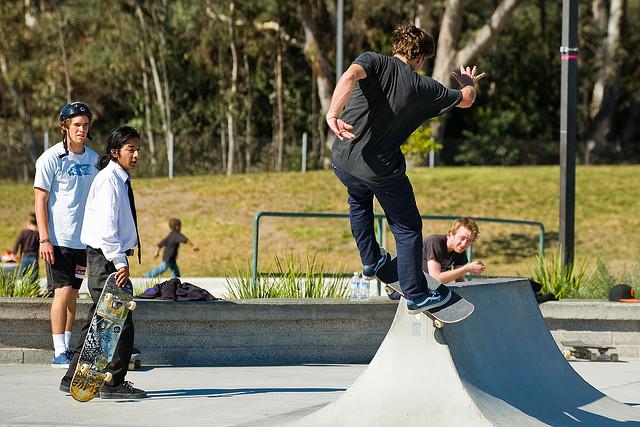How many people are in performing a trick?
Short answer required. 1. How many men are standing on the left?
Give a very brief answer. 2. Are there any females in the picture?
Be succinct. No. 